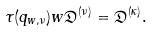Convert formula to latex. <formula><loc_0><loc_0><loc_500><loc_500>\tau ( q _ { w , \nu } ) w \mathfrak { D } ^ { ( \nu ) } = \mathfrak { D } ^ { ( \kappa ) } .</formula> 